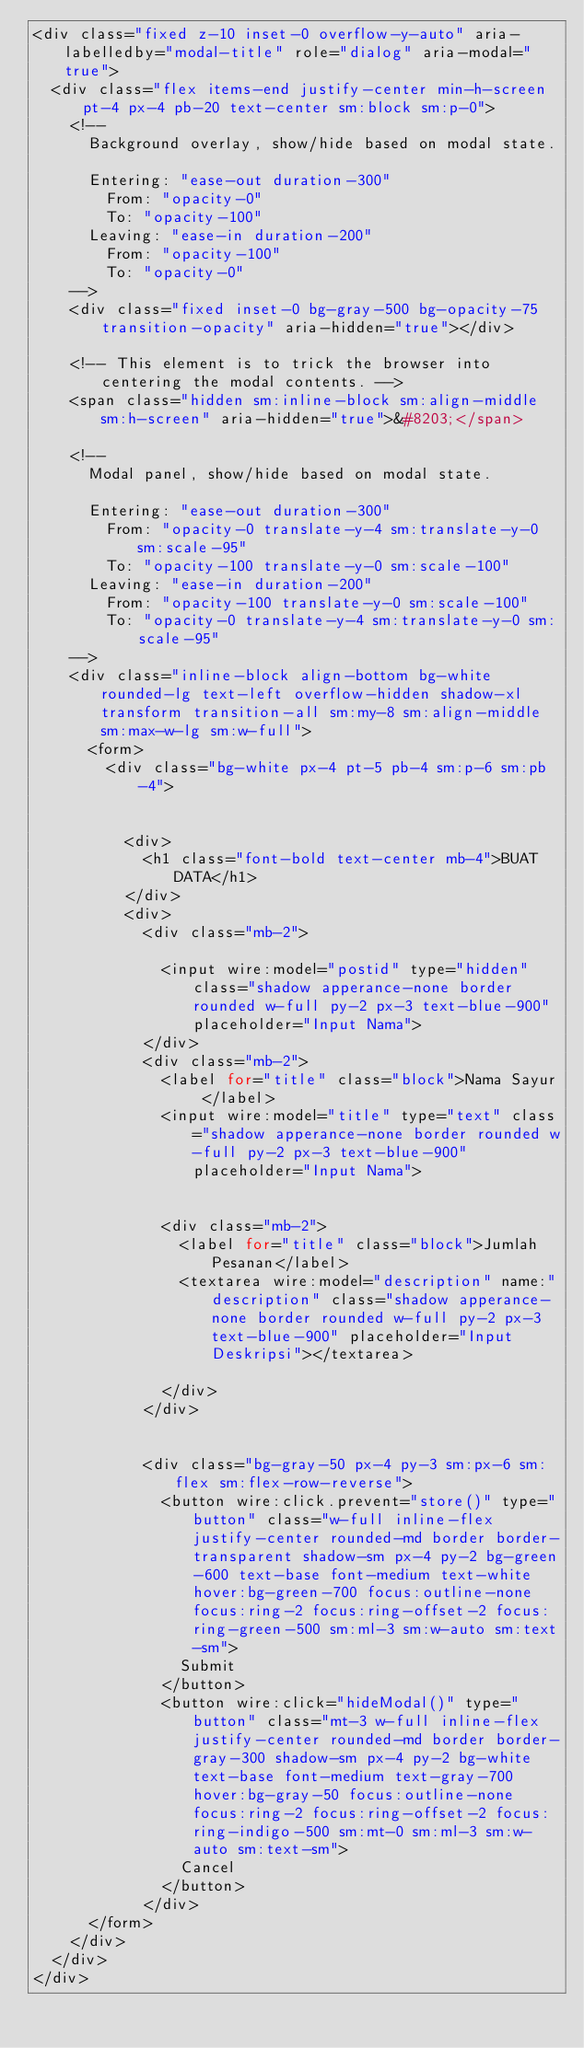Convert code to text. <code><loc_0><loc_0><loc_500><loc_500><_PHP_><div class="fixed z-10 inset-0 overflow-y-auto" aria-labelledby="modal-title" role="dialog" aria-modal="true">
  <div class="flex items-end justify-center min-h-screen pt-4 px-4 pb-20 text-center sm:block sm:p-0">
    <!--
      Background overlay, show/hide based on modal state.

      Entering: "ease-out duration-300"
        From: "opacity-0"
        To: "opacity-100"
      Leaving: "ease-in duration-200"
        From: "opacity-100"
        To: "opacity-0"
    -->
    <div class="fixed inset-0 bg-gray-500 bg-opacity-75 transition-opacity" aria-hidden="true"></div>

    <!-- This element is to trick the browser into centering the modal contents. -->
    <span class="hidden sm:inline-block sm:align-middle sm:h-screen" aria-hidden="true">&#8203;</span>

    <!--
      Modal panel, show/hide based on modal state.

      Entering: "ease-out duration-300"
        From: "opacity-0 translate-y-4 sm:translate-y-0 sm:scale-95"
        To: "opacity-100 translate-y-0 sm:scale-100"
      Leaving: "ease-in duration-200"
        From: "opacity-100 translate-y-0 sm:scale-100"
        To: "opacity-0 translate-y-4 sm:translate-y-0 sm:scale-95"
    -->
    <div class="inline-block align-bottom bg-white rounded-lg text-left overflow-hidden shadow-xl transform transition-all sm:my-8 sm:align-middle sm:max-w-lg sm:w-full">
      <form>
        <div class="bg-white px-4 pt-5 pb-4 sm:p-6 sm:pb-4">


          <div>
            <h1 class="font-bold text-center mb-4">BUAT DATA</h1>
          </div>
          <div>
            <div class="mb-2">

              <input wire:model="postid" type="hidden" class="shadow apperance-none border rounded w-full py-2 px-3 text-blue-900" placeholder="Input Nama">
            </div>
            <div class="mb-2">
              <label for="title" class="block">Nama Sayur </label>
              <input wire:model="title" type="text" class="shadow apperance-none border rounded w-full py-2 px-3 text-blue-900" placeholder="Input Nama">


              <div class="mb-2">
                <label for="title" class="block">Jumlah Pesanan</label>
                <textarea wire:model="description" name:"description" class="shadow apperance-none border rounded w-full py-2 px-3 text-blue-900" placeholder="Input Deskripsi"></textarea>

              </div>
            </div>


            <div class="bg-gray-50 px-4 py-3 sm:px-6 sm:flex sm:flex-row-reverse">
              <button wire:click.prevent="store()" type="button" class="w-full inline-flex justify-center rounded-md border border-transparent shadow-sm px-4 py-2 bg-green-600 text-base font-medium text-white hover:bg-green-700 focus:outline-none focus:ring-2 focus:ring-offset-2 focus:ring-green-500 sm:ml-3 sm:w-auto sm:text-sm">
                Submit
              </button>
              <button wire:click="hideModal()" type="button" class="mt-3 w-full inline-flex justify-center rounded-md border border-gray-300 shadow-sm px-4 py-2 bg-white text-base font-medium text-gray-700 hover:bg-gray-50 focus:outline-none focus:ring-2 focus:ring-offset-2 focus:ring-indigo-500 sm:mt-0 sm:ml-3 sm:w-auto sm:text-sm">
                Cancel
              </button>
            </div>
      </form>
    </div>
  </div>
</div></code> 